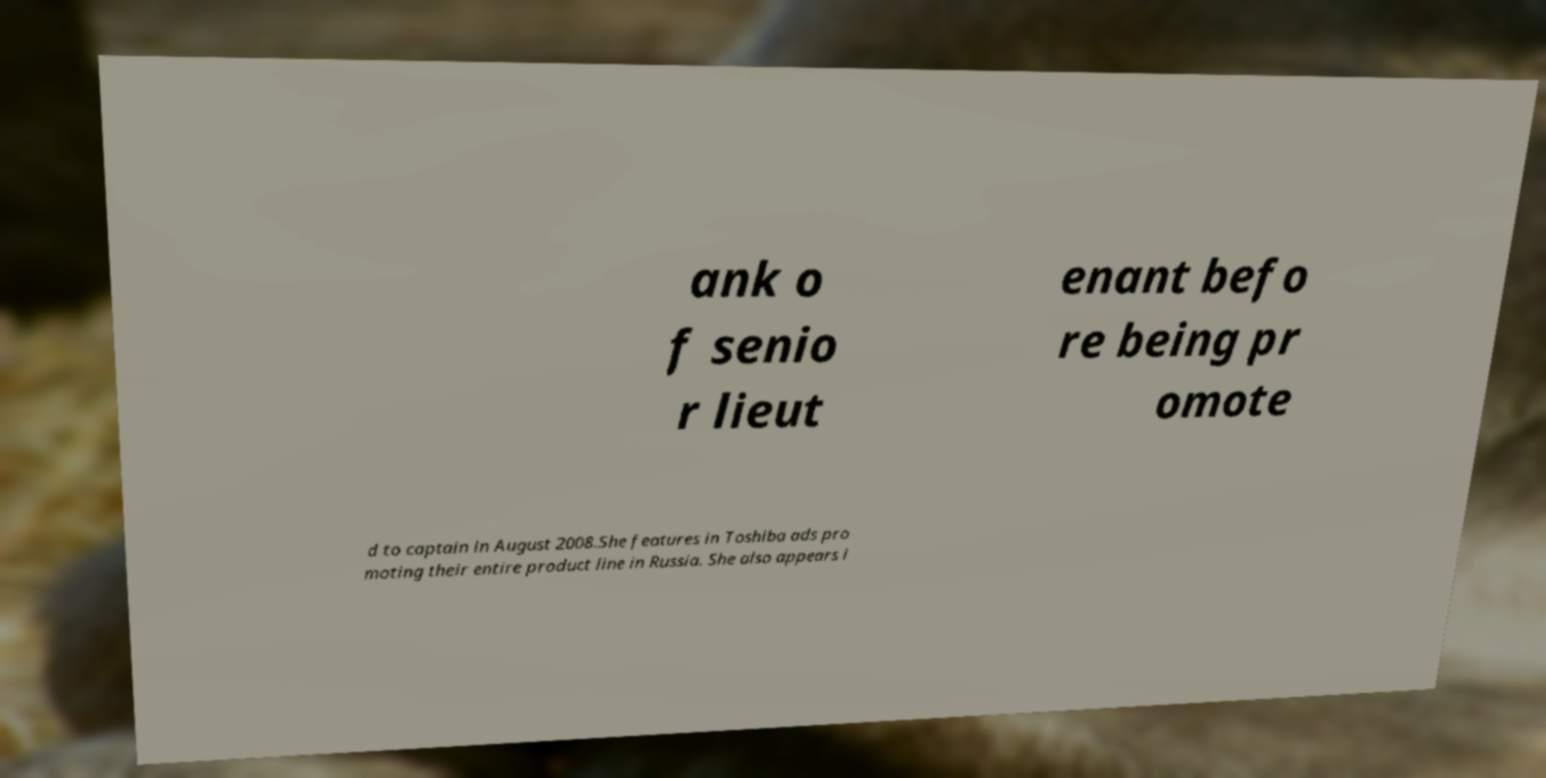Can you accurately transcribe the text from the provided image for me? ank o f senio r lieut enant befo re being pr omote d to captain in August 2008.She features in Toshiba ads pro moting their entire product line in Russia. She also appears i 